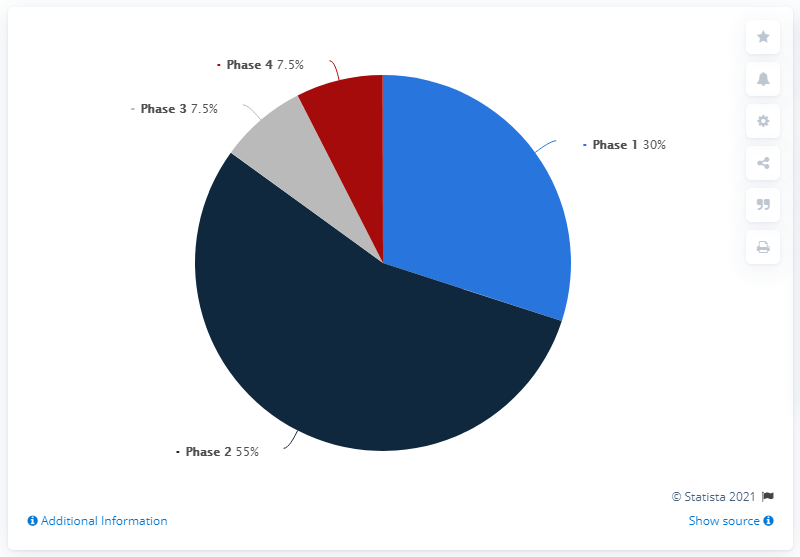Point out several critical features in this image. The ratio of Phase 1 to Phase 2 is 0.545454545... The Phase 2 dominates the chart. 